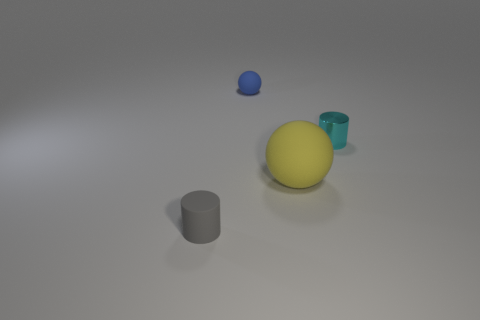Are there any other things that have the same shape as the yellow rubber thing?
Your answer should be very brief. Yes. Do the sphere that is in front of the cyan cylinder and the tiny cylinder behind the gray matte thing have the same material?
Keep it short and to the point. No. What is the material of the tiny ball?
Ensure brevity in your answer.  Rubber. How many other spheres have the same material as the blue ball?
Offer a very short reply. 1. What number of rubber things are either small cylinders or tiny gray cylinders?
Your response must be concise. 1. Is the shape of the small rubber object on the right side of the tiny gray thing the same as the object that is left of the tiny blue rubber sphere?
Keep it short and to the point. No. There is a object that is behind the gray rubber thing and in front of the tiny cyan cylinder; what is its color?
Offer a very short reply. Yellow. There is a cylinder behind the gray matte thing; is its size the same as the ball that is right of the blue rubber thing?
Your answer should be very brief. No. What number of big balls are the same color as the metallic object?
Provide a short and direct response. 0. How many large things are either cyan balls or gray cylinders?
Your answer should be compact. 0. 